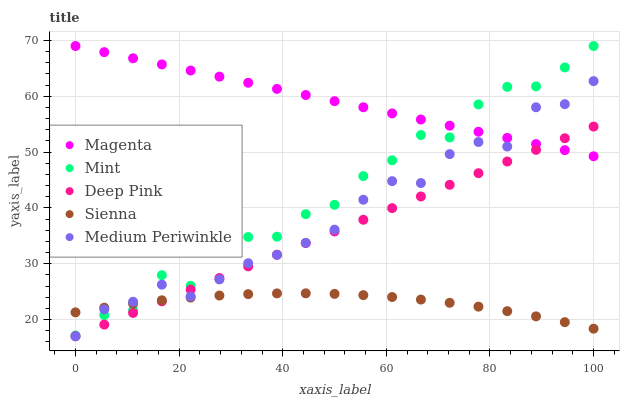Does Sienna have the minimum area under the curve?
Answer yes or no. Yes. Does Magenta have the maximum area under the curve?
Answer yes or no. Yes. Does Medium Periwinkle have the minimum area under the curve?
Answer yes or no. No. Does Medium Periwinkle have the maximum area under the curve?
Answer yes or no. No. Is Deep Pink the smoothest?
Answer yes or no. Yes. Is Mint the roughest?
Answer yes or no. Yes. Is Medium Periwinkle the smoothest?
Answer yes or no. No. Is Medium Periwinkle the roughest?
Answer yes or no. No. Does Medium Periwinkle have the lowest value?
Answer yes or no. Yes. Does Magenta have the lowest value?
Answer yes or no. No. Does Mint have the highest value?
Answer yes or no. Yes. Does Medium Periwinkle have the highest value?
Answer yes or no. No. Is Deep Pink less than Mint?
Answer yes or no. Yes. Is Mint greater than Deep Pink?
Answer yes or no. Yes. Does Sienna intersect Deep Pink?
Answer yes or no. Yes. Is Sienna less than Deep Pink?
Answer yes or no. No. Is Sienna greater than Deep Pink?
Answer yes or no. No. Does Deep Pink intersect Mint?
Answer yes or no. No. 